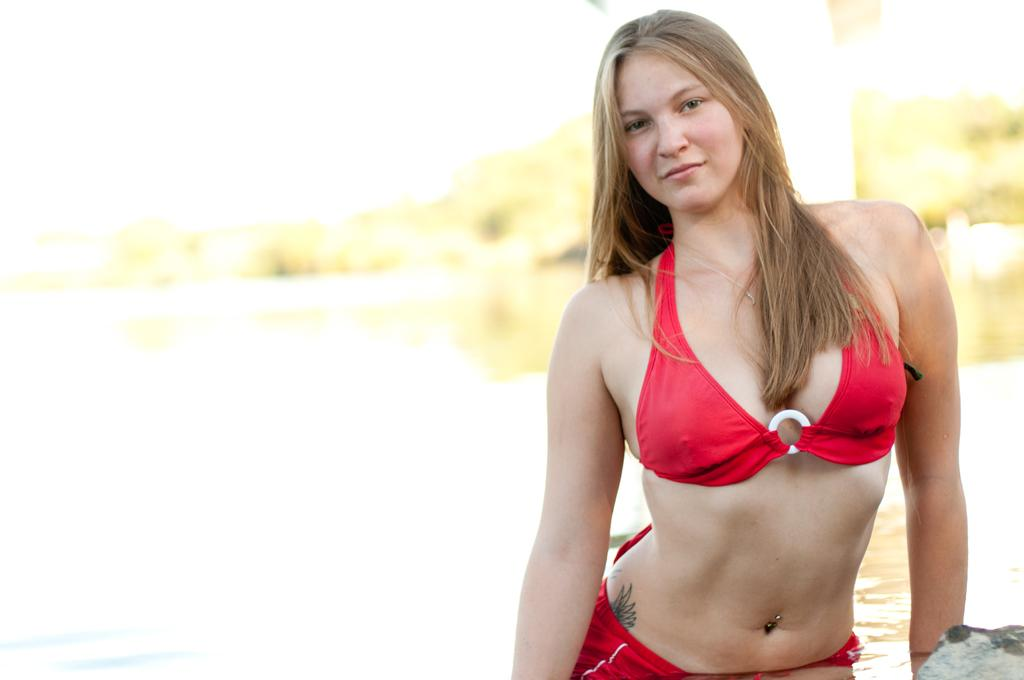Who is the main subject in the foreground of the image? There is a woman in the foreground of the image. What can be seen in the background of the image? Water, trees, and the sky are visible in the background of the image. What might be the location of the image based on the background? The image may have been taken near a lake, given the presence of water and trees. How does the woman breathe underwater in the image? The woman is not underwater in the image; she is in the foreground, and there is water visible in the background. 